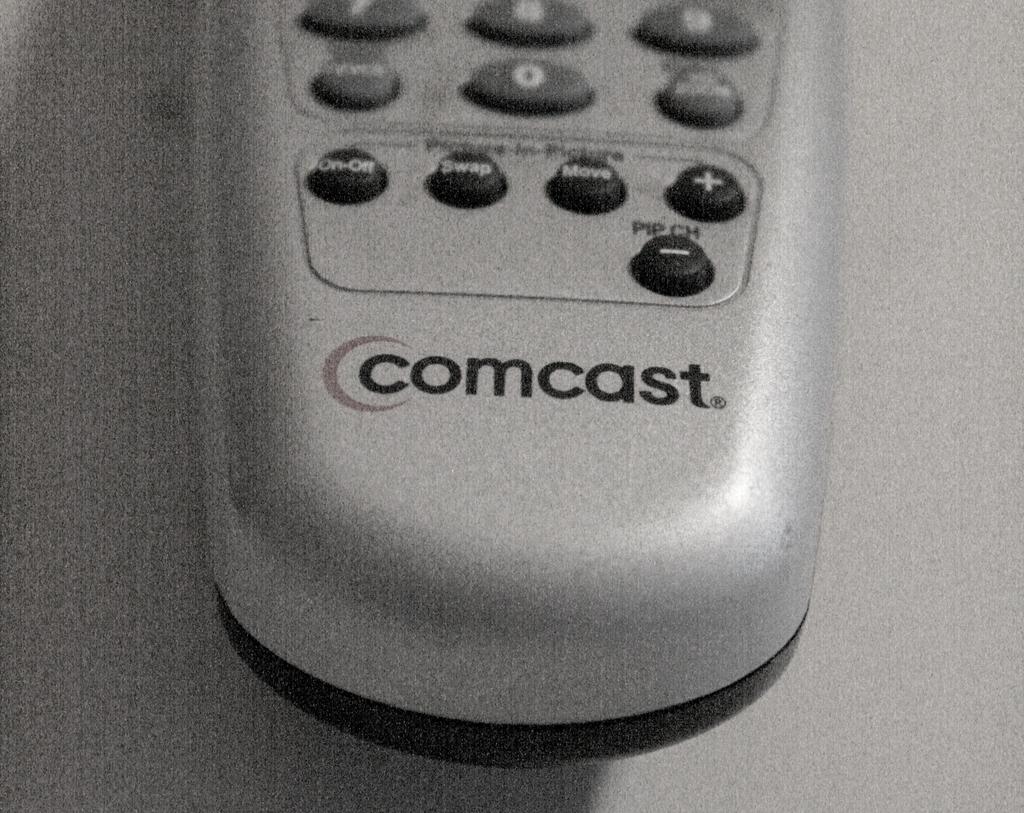What are the numbers at the bottom?
Provide a succinct answer. 0. 